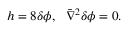<formula> <loc_0><loc_0><loc_500><loc_500>h = 8 \delta \phi , \bar { \nabla } ^ { 2 } \delta \phi = 0 .</formula> 